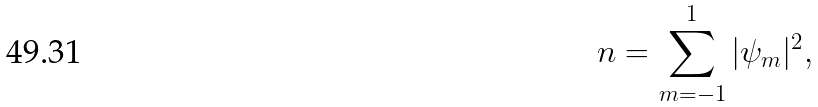<formula> <loc_0><loc_0><loc_500><loc_500>n = \sum _ { m = - 1 } ^ { 1 } | \psi _ { m } | ^ { 2 } ,</formula> 